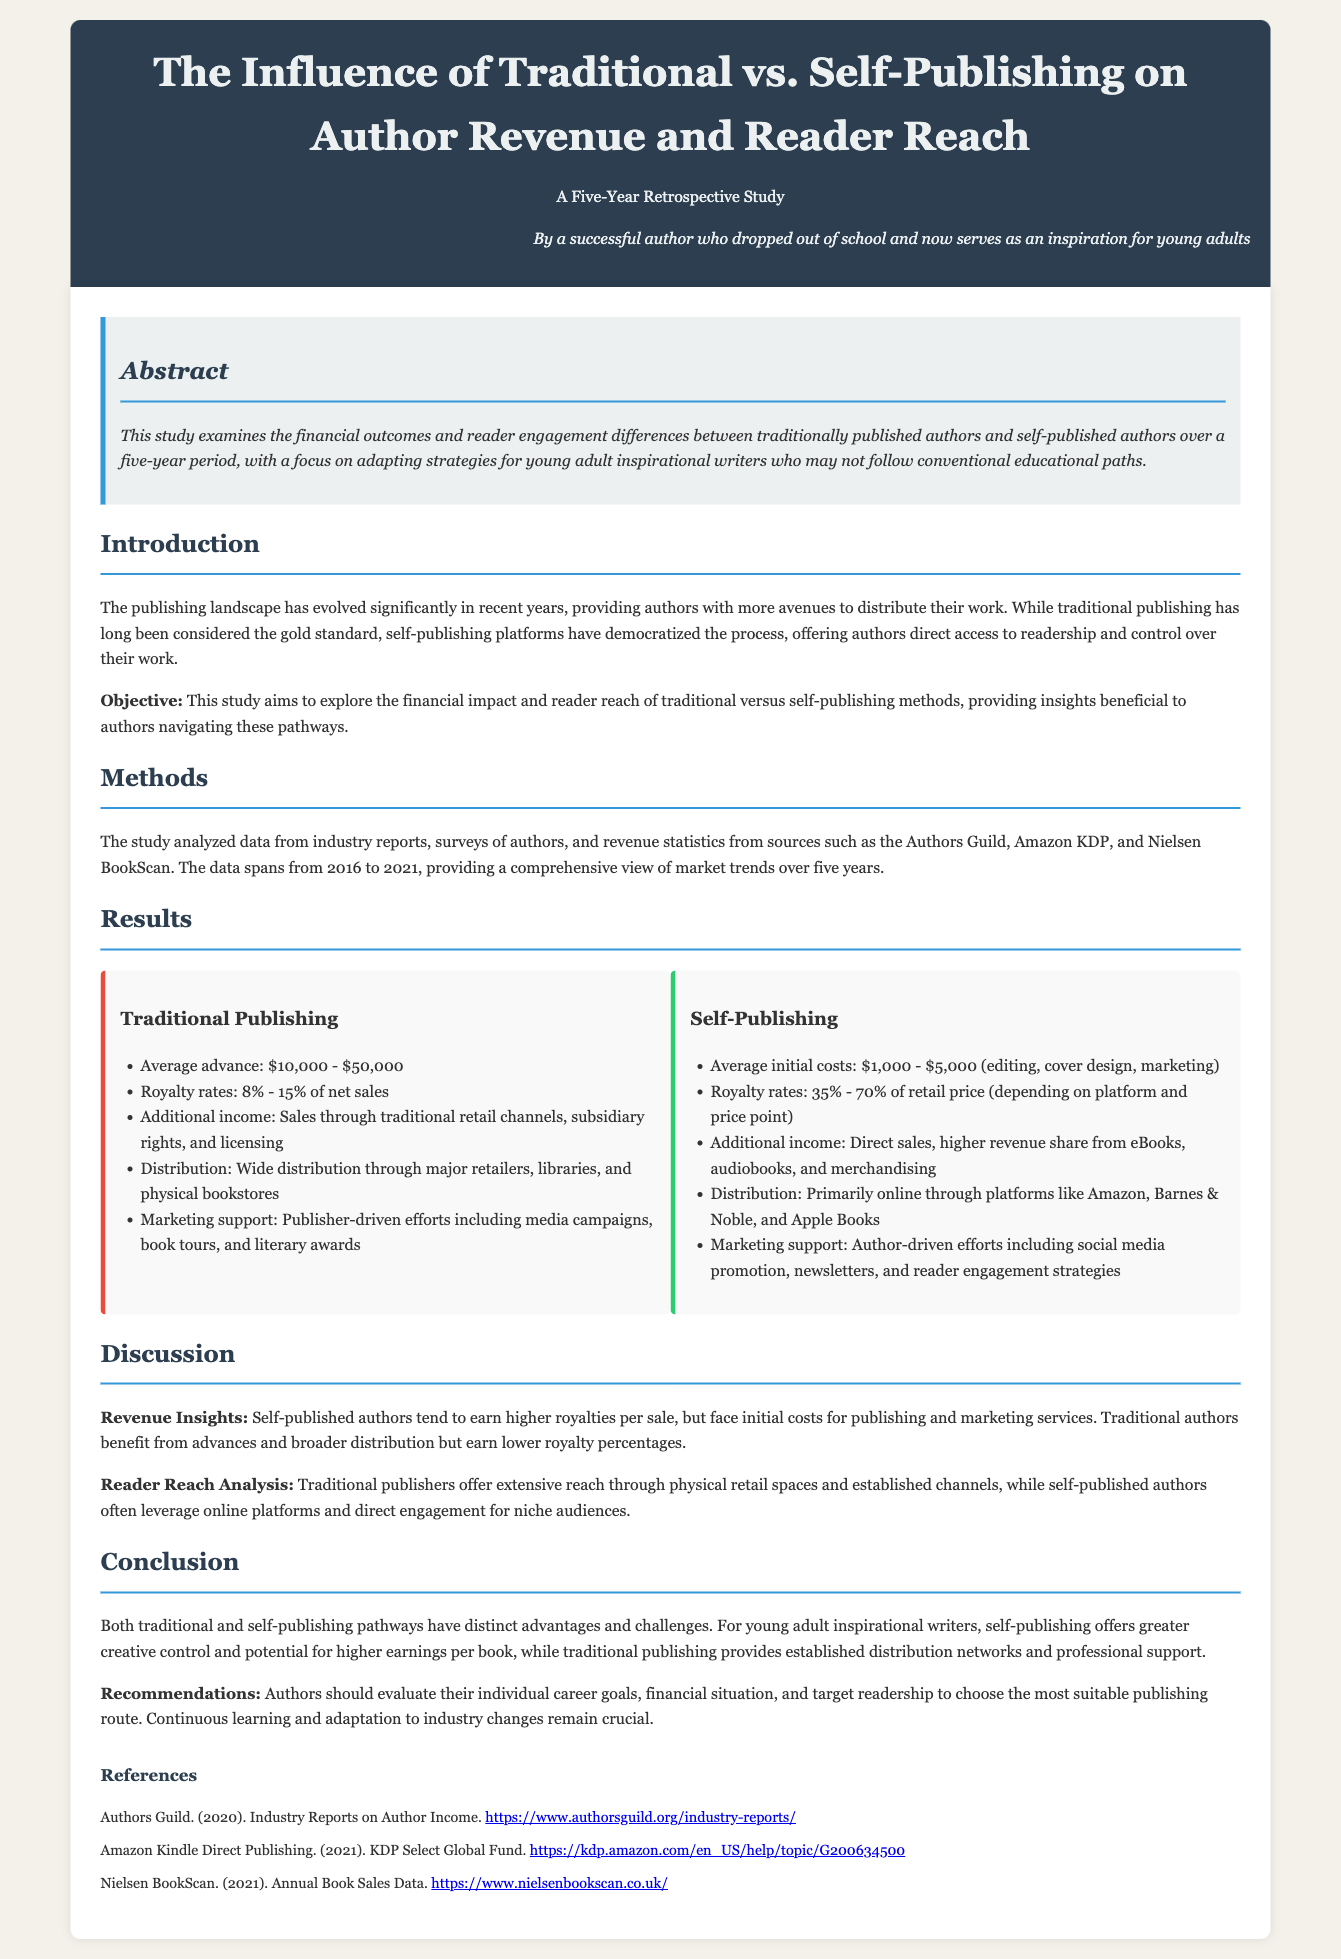What is the average advance for traditional publishing? The average advance for traditional publishing ranges from $10,000 to $50,000 according to the document.
Answer: $10,000 - $50,000 What is the royalty rate for self-publishing? The document states that the royalty rates for self-publishing are between 35% and 70% of the retail price.
Answer: 35% - 70% What is one additional income source for traditional publishing? The document mentions multiple additional income sources, one of which is sales through traditional retail channels.
Answer: Sales through traditional retail channels What years does the study's data analyze? The data spans from 2016 to 2021, providing insights for those specific years according to the study.
Answer: 2016 to 2021 What is the primary distribution method for self-publishing? The primary distribution method for self-publishing according to the document is online platforms.
Answer: Online platforms What is the objective of this study? The document indicates that the objective is to explore the financial impact and reader reach of traditional versus self-publishing methods.
Answer: Explore the financial impact and reader reach Which publishing method offers higher royalties per sale? The study highlights that self-published authors tend to earn higher royalties per sale.
Answer: Self-publishing What type of support do traditional publishers provide? The document specifies that traditional publishers offer marketing support, which includes publisher-driven efforts.
Answer: Marketing support What is a recommendation for authors mentioned in the conclusion? One recommendation for authors is to evaluate their individual career goals to choose the most suitable publishing route.
Answer: Evaluate their individual career goals 